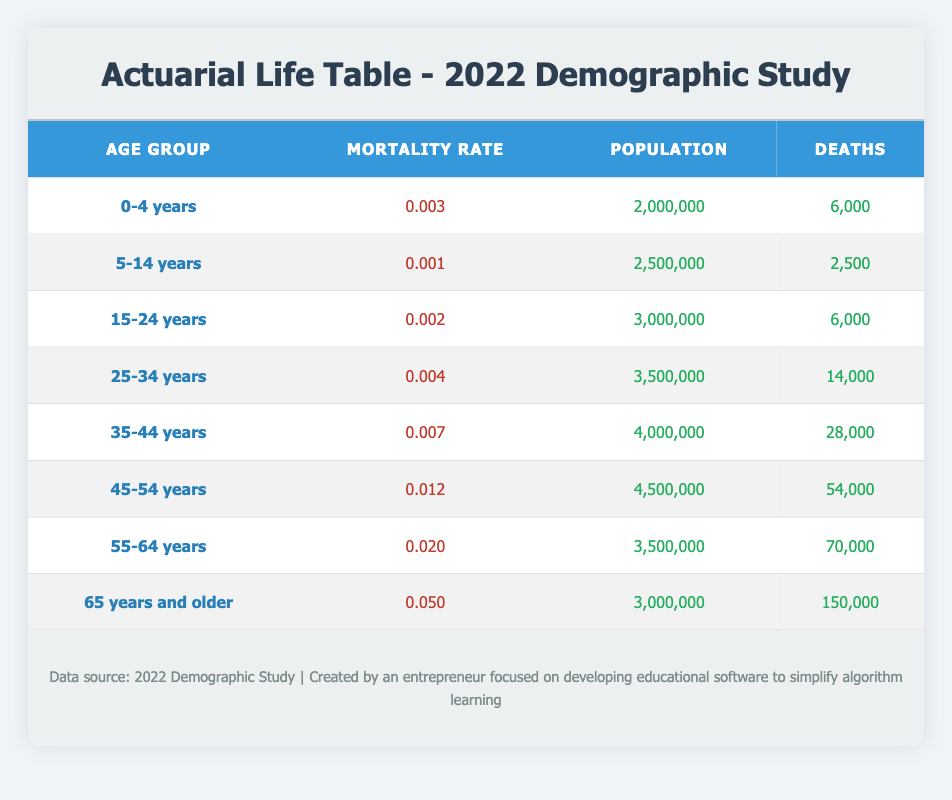What is the mortality rate for the age group 15-24 years? The mortality rate for the age group 15-24 years can be found directly in the table under the column labeled "Mortality Rate" for that specific age group. The rate is listed as 0.002.
Answer: 0.002 How many deaths occurred in the age group 45-54 years? The number of deaths in the age group 45-54 years is located in the "Deaths" column corresponding to that age group. The table shows that there were 54,000 deaths.
Answer: 54,000 What is the total population represented in the age group 25-34 years and 35-44 years combined? To find the total population of the two age groups, we sum the populations of each age group. 3,500,000 (for 25-34 years) + 4,000,000 (for 35-44 years) equals 7,500,000.
Answer: 7,500,000 Is the mortality rate for the age group 65 years and older greater than that for the age group 55-64 years? By comparing the mortality rates from the table, the mortality rate for the age group 65 years and older is 0.050, while for the age group 55-64 years it is 0.020. Therefore, the statement is true.
Answer: Yes What is the average mortality rate across all age groups in the table? To calculate the average mortality rate, sum all the individual mortality rates and divide by the number of age groups. The rates are 0.003 + 0.001 + 0.002 + 0.004 + 0.007 + 0.012 + 0.020 + 0.050, which totals 0.099. Dividing by 8 (the number of age groups) gives an average of 0.012375.
Answer: 0.012375 What group has the highest number of deaths? By examining the "Deaths" column in the table, we see that the age group 65 years and older has the highest number of deaths at 150,000.
Answer: 65 years and older What is the difference in mortality rates between the age groups 0-4 years and 45-54 years? To find the difference, subtract the mortality rate of the younger group (0.003 for 0-4 years) from that of the older group (0.012 for 45-54 years). Thus, 0.012 - 0.003 equals 0.009.
Answer: 0.009 How many total deaths occurred for all age groups combined? To find the total deaths, add the deaths across all age groups listed in the table: 6,000 + 2,500 + 6,000 + 14,000 + 28,000 + 54,000 + 70,000 + 150,000. This sums to 330,500 total deaths across all age groups.
Answer: 330,500 Was the mortality rate for 5-14 years higher than that for 15-24 years? By comparing the rates in the table, the mortality rate for 5-14 years is 0.001 and for 15-24 years is 0.002. Therefore, the statement is false as 0.001 is lower than 0.002.
Answer: No 